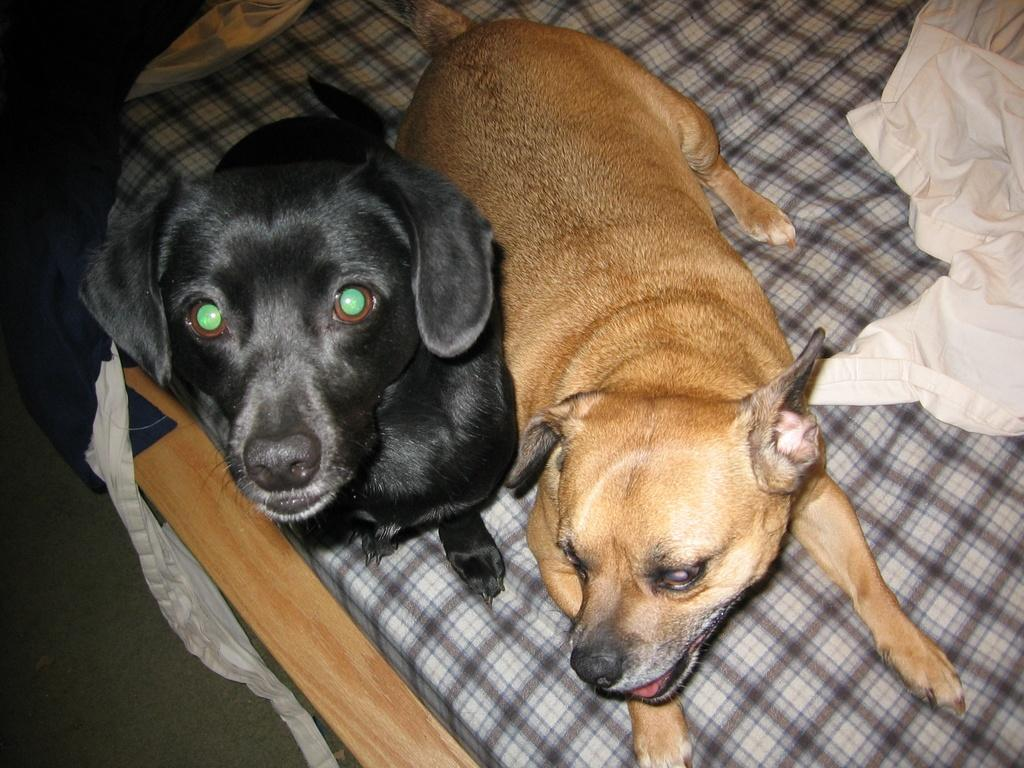How many dogs are in the image? There are two dogs in the image. What are the colors of the dogs? One dog is brown, and the other is black. Where are the dogs sitting? The dogs are sitting on a bed. What is to the right of the dogs? There is a white cloth to the right of the dogs. What can be seen at the bottom of the image? There is a floor visible at the bottom of the image. What type of nut is being used as a toy by the dogs in the image? There is no nut present in the image; the dogs are sitting on a bed. Can you see any feathers or steel objects in the image? No, there are no feathers or steel objects visible in the image. 